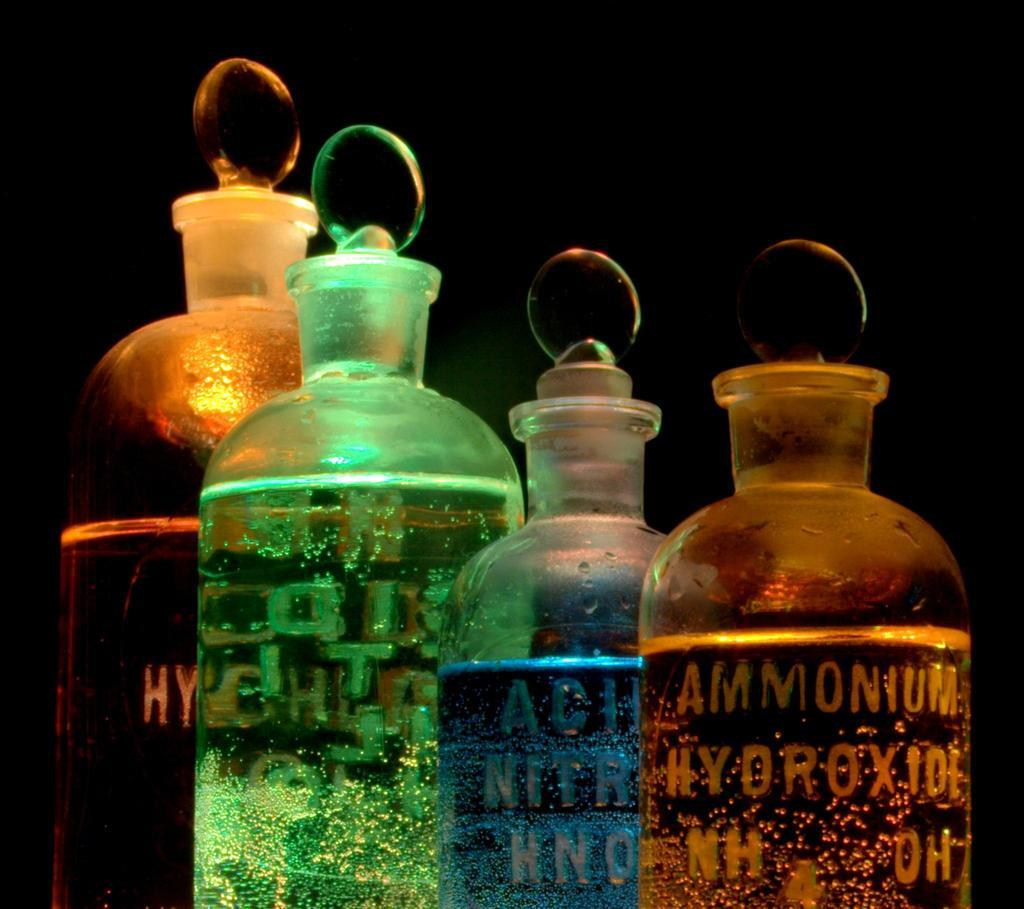How many bottles are visible in the image? There are four bottles in the image. What is the condition of the liquids in the bottles? Some of the bottles contain liquids. Can you describe the color of the liquids in two of the bottles? One bottle has a blue liquid, and one bottle has a green liquid. How are the bottles sealed to prevent spills? All the bottles are sealed with caps. What is the title of the book that the actor is holding in the image? There is no book or actor present in the image; it only features four bottles. 